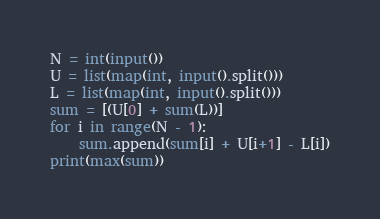Convert code to text. <code><loc_0><loc_0><loc_500><loc_500><_Python_>N = int(input())
U = list(map(int, input().split()))
L = list(map(int, input().split()))
sum = [(U[0] + sum(L))]
for i in range(N - 1):
	sum.append(sum[i] + U[i+1] - L[i])
print(max(sum))</code> 